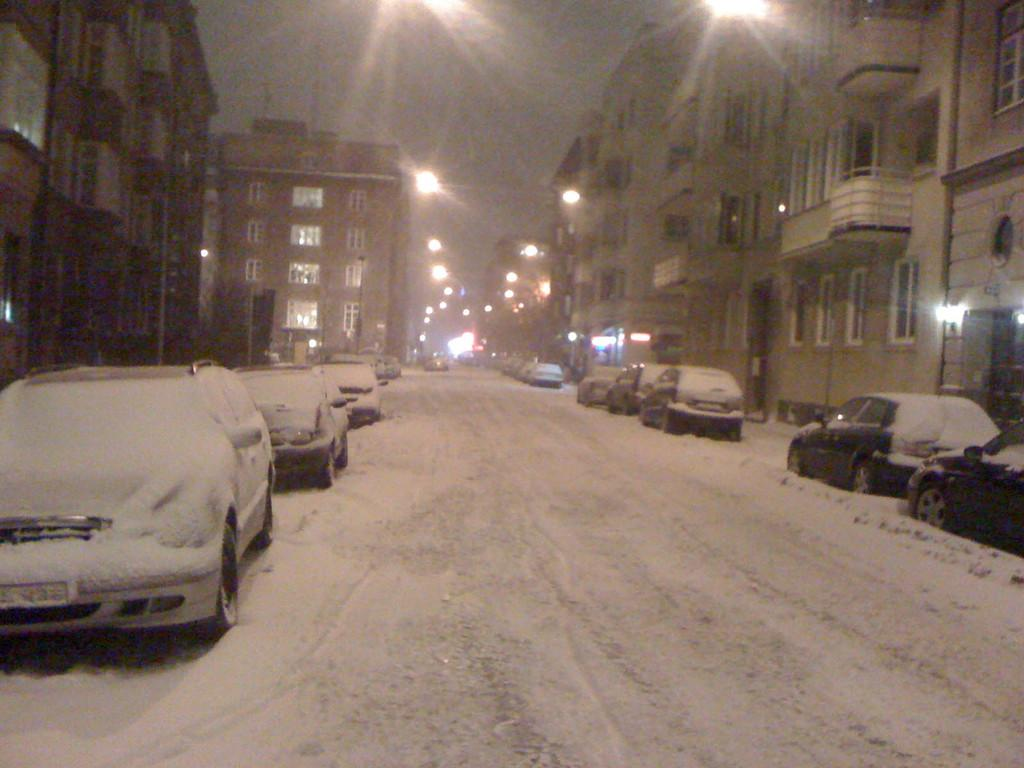What can be seen on the road in the image? There are motor vehicles on the road in the image. How are the motor vehicles affected by the weather? The motor vehicles are covered with snow. What type of structures are present along the road? There are street poles and buildings visible in the image. What is used to illuminate the road at night? There are street lights in the image. What part of the natural environment is visible in the image? The sky is visible in the image. How many pizzas are being delivered by the motor vehicles in the image? There is no indication of pizzas or delivery in the image; it only shows motor vehicles covered in snow on the road. 